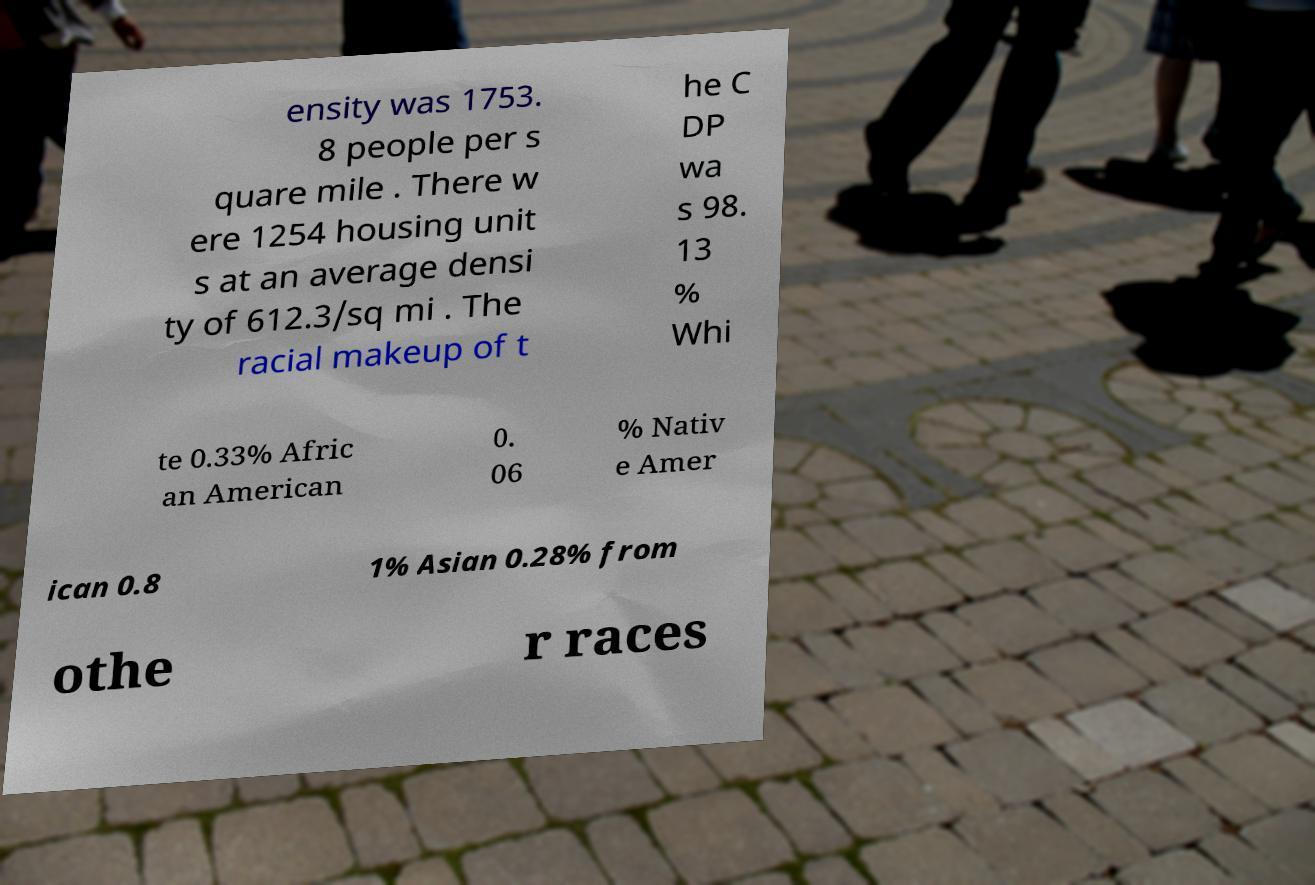Can you accurately transcribe the text from the provided image for me? ensity was 1753. 8 people per s quare mile . There w ere 1254 housing unit s at an average densi ty of 612.3/sq mi . The racial makeup of t he C DP wa s 98. 13 % Whi te 0.33% Afric an American 0. 06 % Nativ e Amer ican 0.8 1% Asian 0.28% from othe r races 